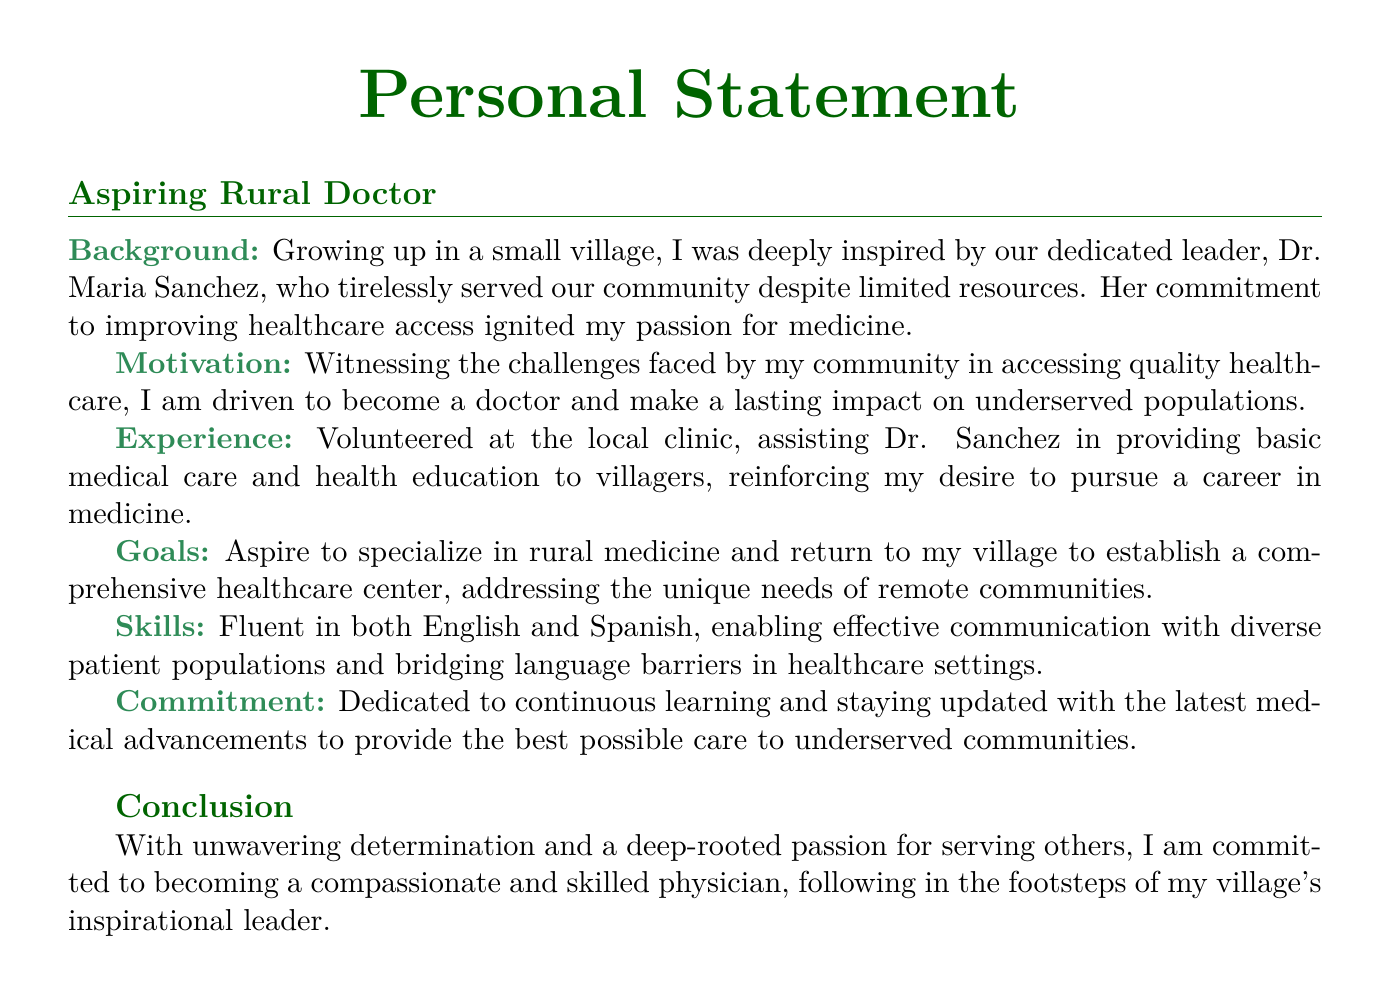What is the name of the village leader who inspired the author? The author's inspiration for pursuing medicine comes from Dr. Maria Sanchez, who served the community.
Answer: Dr. Maria Sanchez What unique needs does the author aspire to address in their village? The author aims to establish a healthcare center to meet the specific healthcare challenges faced by remote communities.
Answer: Unique needs of remote communities What language skills does the author possess? The author emphasizes their ability to communicate effectively with diverse patient populations due to being fluent in these languages.
Answer: English and Spanish What type of medicine does the author aspire to specialize in? This information specifies the author's target area of focus within the medical field, which is rural medicine.
Answer: Rural medicine What experience does the author mention that reinforced their desire to pursue medicine? The author volunteered at the local clinic, providing support in medical care and health education, which solidified their commitment to the field.
Answer: Volunteered at the local clinic What commitment does the author express regarding their medical career? This aspect highlights the author's dedication to providing the best care possible for underserved communities through ongoing learning.
Answer: Continuous learning 